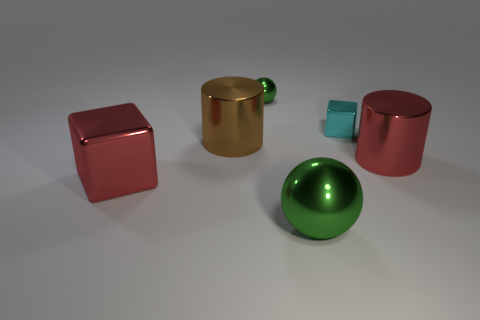What color is the large cube?
Your answer should be very brief. Red. What number of other things are there of the same shape as the big green thing?
Provide a short and direct response. 1. Are there an equal number of big red metallic blocks to the right of the big metallic cube and cyan objects that are behind the cyan object?
Your answer should be compact. Yes. What is the material of the tiny ball?
Keep it short and to the point. Metal. What is the block that is left of the tiny green shiny thing made of?
Provide a succinct answer. Metal. Is there anything else that is made of the same material as the big red cube?
Offer a very short reply. Yes. Is the number of red metal cylinders that are behind the brown thing greater than the number of large red cubes?
Your answer should be compact. No. There is a metal block on the left side of the green sphere that is left of the large green sphere; is there a large brown object in front of it?
Ensure brevity in your answer.  No. There is a small green thing; are there any red cylinders behind it?
Provide a short and direct response. No. What number of big objects have the same color as the tiny metallic ball?
Offer a terse response. 1. 